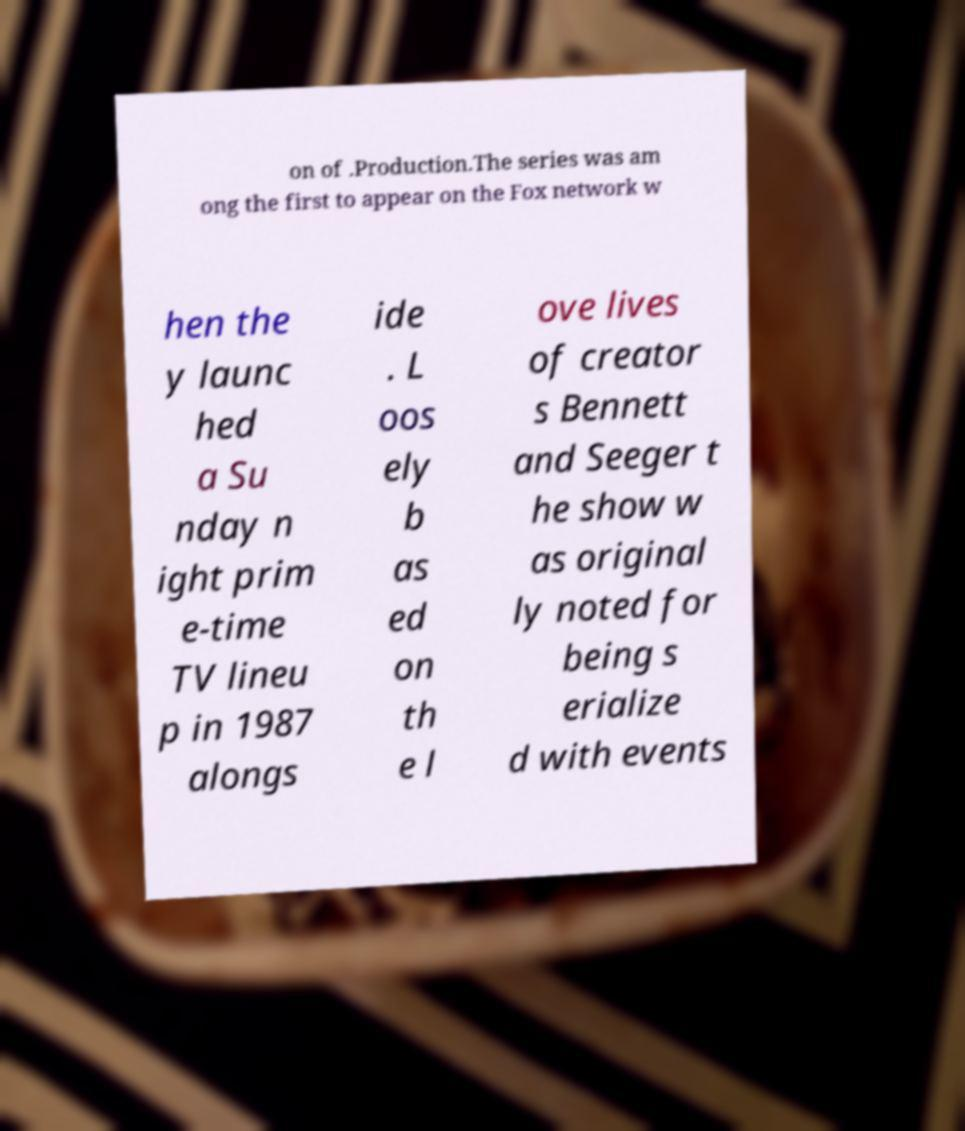Please identify and transcribe the text found in this image. on of .Production.The series was am ong the first to appear on the Fox network w hen the y launc hed a Su nday n ight prim e-time TV lineu p in 1987 alongs ide . L oos ely b as ed on th e l ove lives of creator s Bennett and Seeger t he show w as original ly noted for being s erialize d with events 